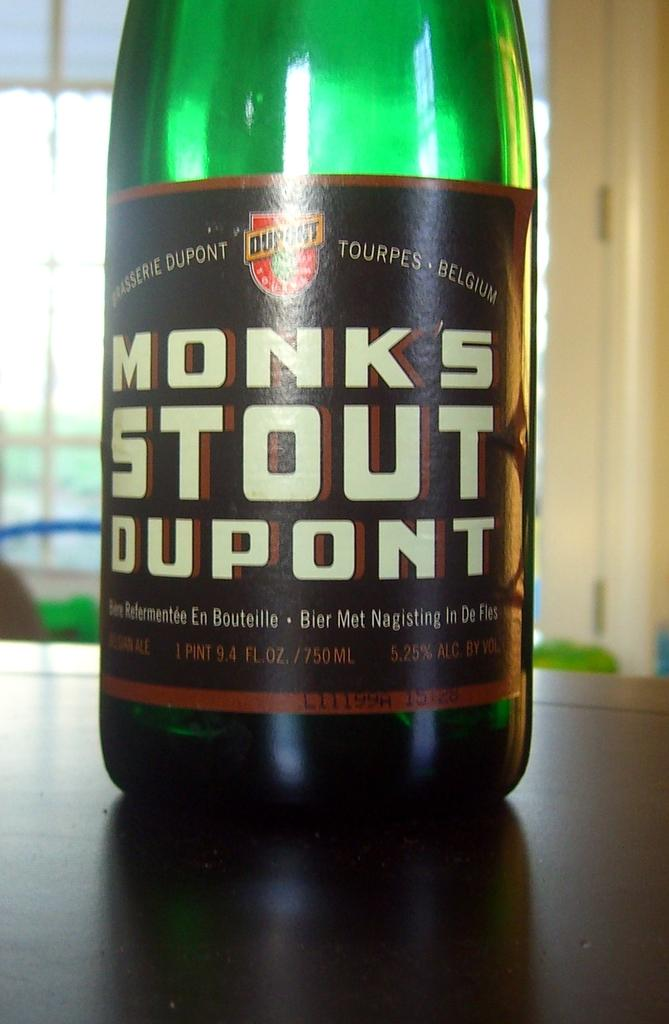What is the main subject in the center of the image? There is a bottle named "monks" in the center of the image. What is located in front of the bottle? There is a table in front of the bottle. What can be seen in the background of the image? There is a wall in the background of the image. Can you tell me how many spies are hiding behind the wall in the image? There is no indication of spies or any hidden figures in the image; it only features a bottle named "monks," a table, and a wall. 